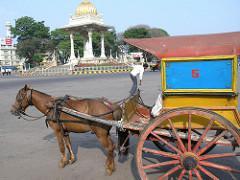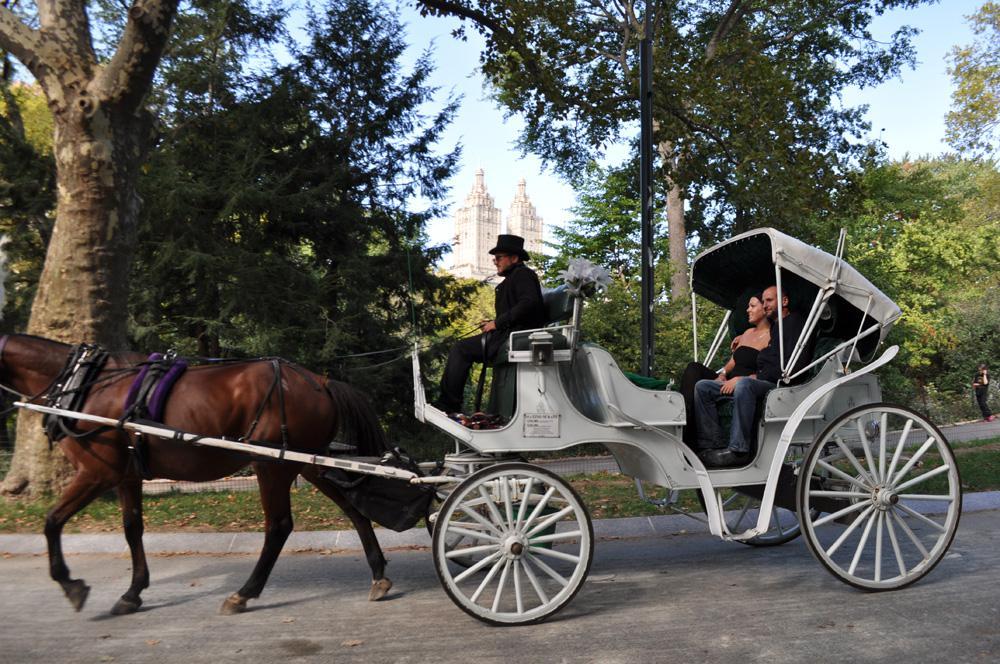The first image is the image on the left, the second image is the image on the right. Evaluate the accuracy of this statement regarding the images: "The left and right image contains a total of two horses.". Is it true? Answer yes or no. Yes. The first image is the image on the left, the second image is the image on the right. Analyze the images presented: Is the assertion "The right image shows a four-wheeled white carriage with some type of top, pulled by one horse facing leftward." valid? Answer yes or no. Yes. 